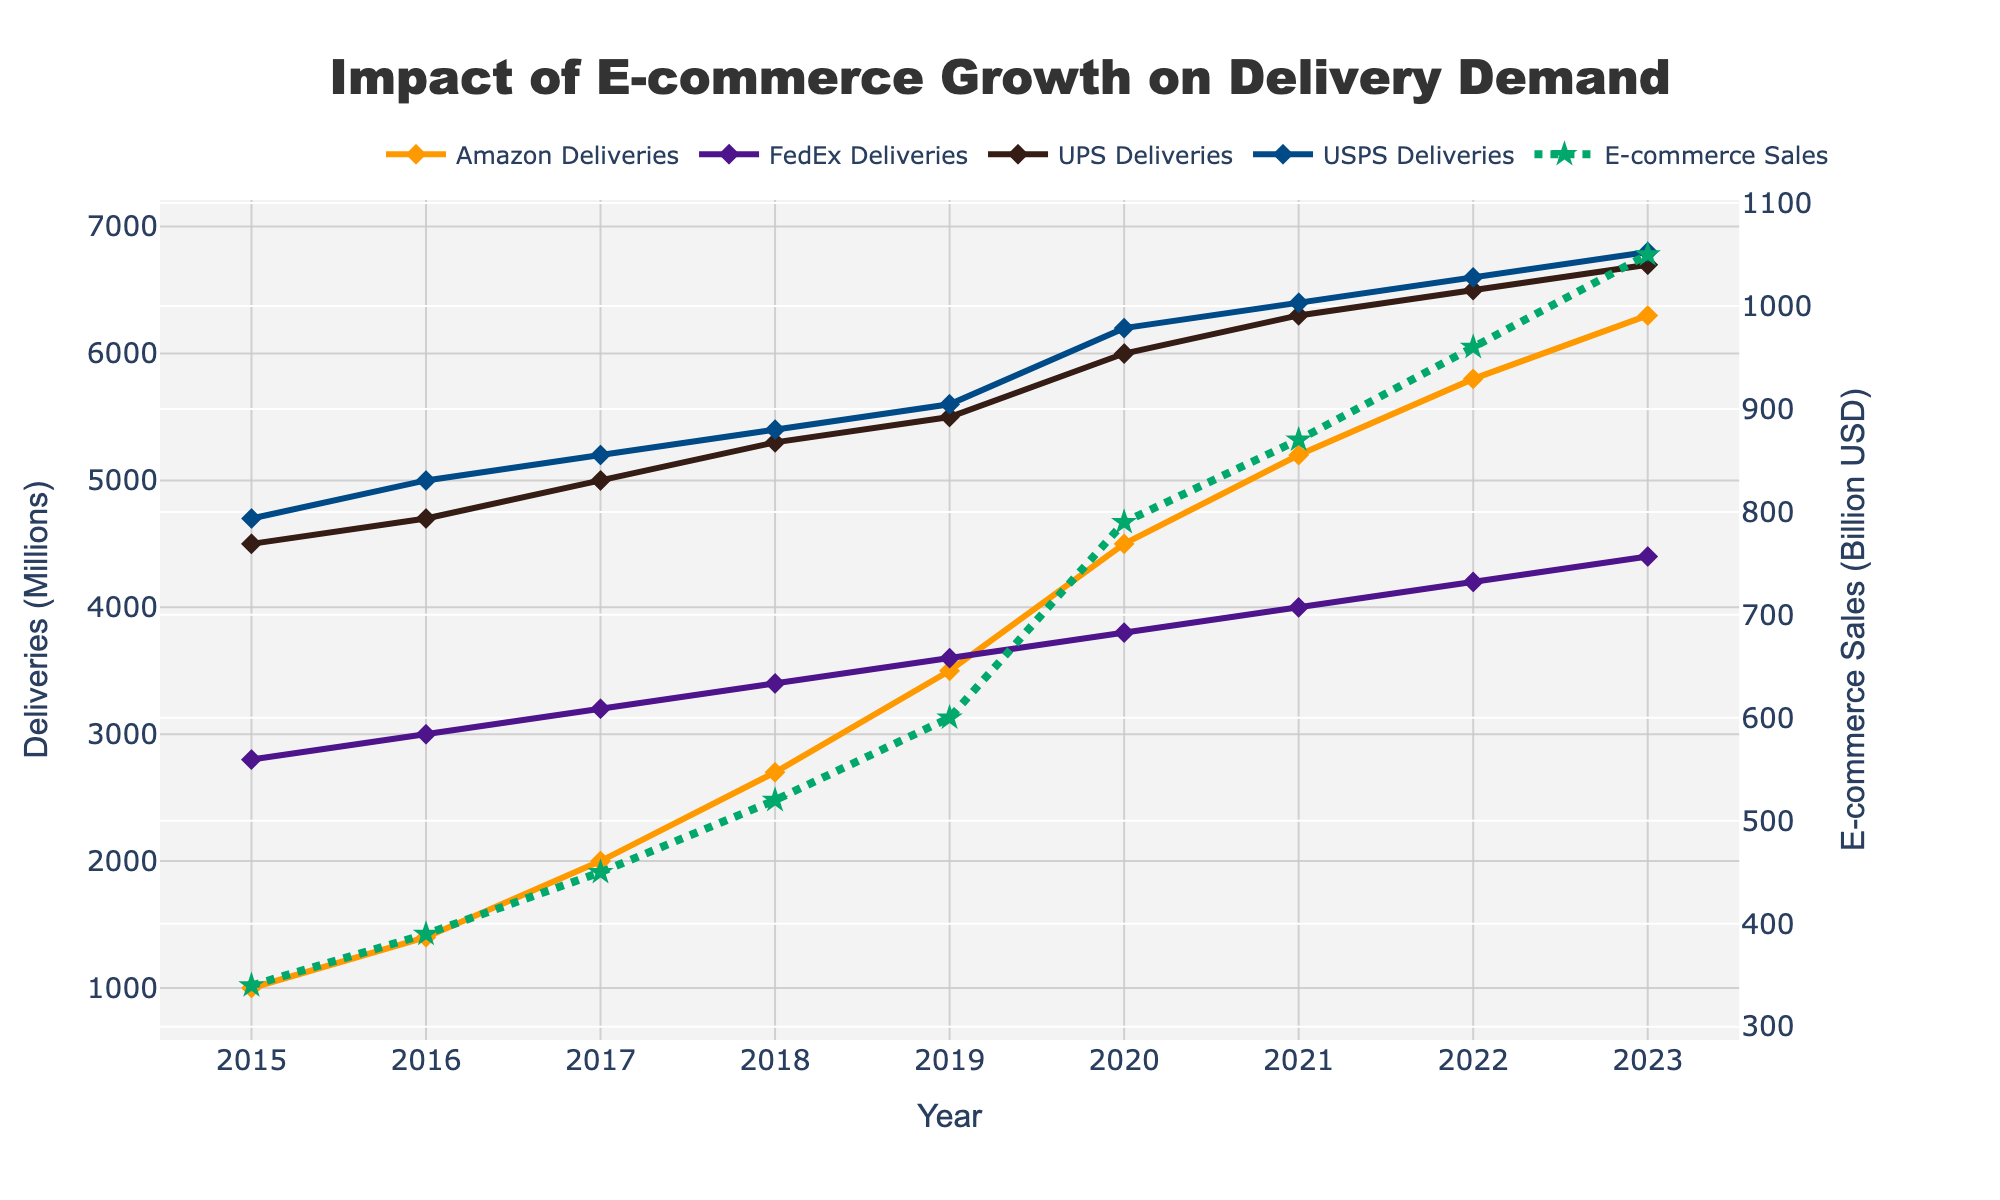What is the total number of deliveries made by Amazon and USPS in 2020? The plot shows the deliveries made by Amazon and USPS in millions. In 2020, Amazon made 4500 million deliveries and USPS made 6200 million deliveries. Adding these numbers gives 4500 + 6200 = 10700 million deliveries.
Answer: 10700 million Which company had the highest number of deliveries in 2019, and what was the value? Observing the plot for deliveries in 2019, USPS had the highest number with 5600 million deliveries.
Answer: USPS, 5600 million In which year did FedEx and UPS deliveries become equal, and what was their value? Referring to the graph, deliveries for FedEx and UPS were equal in 2015, both being 4500 million deliveries.
Answer: 2015, 4500 million What is the average growth in e-commerce sales (in billion USD) from 2016 to 2018? To find the average growth in sales from 2016 to 2018, calculate the growth for each year first: (2017 - 2016) = 450 - 390 = 60, (2018 - 2017) = 520 - 450 = 70. Then, average these growths: (60 + 70)/2 = 65 billion USD.
Answer: 65 billion USD Which company showed the most significant increase in deliveries from 2019 to 2020, and by how much? Comparing the changes from 2019 to 2020, Amazon's deliveries increased from 3500 million to 4500 million, a growth of 1000 million. This is the most significant increase among the companies.
Answer: Amazon, 1000 million What is the difference in total e-commerce sales between 2018 and 2023? From the graph, total e-commerce sales in 2018 were 520 billion USD, and in 2023 they were 1050 billion USD. The difference is 1050 - 520 = 530 billion USD.
Answer: 530 billion USD What is the trend in UPS deliveries from 2015 to 2023? Observing UPS deliveries over the years, the deliveries steadily increased from 4500 million in 2015 to 6700 million in 2023.
Answer: Increasing In which year did Amazon surpass 5000 million deliveries, and by how much did its deliveries increase in that year? From the graph, Amazon surpassed 5000 million deliveries in 2021, growing from 4500 million in 2020 to 5200 million in 2021, an increase of 700 million deliveries.
Answer: 2021, 700 million What is the combined number of deliveries made by FedEx and USPS in 2022? Sum the deliveries made by FedEx and USPS in 2022: FedEx had 4200 million and USPS had 6600 million. So, 4200 + 6600 = 10800 million deliveries.
Answer: 10800 million How has the color used for the e-commerce sales trend line been represented in the graph? Observing the plot, the e-commerce sales trend line is represented by a green color with a dotted line pattern.
Answer: Green, dotted line 